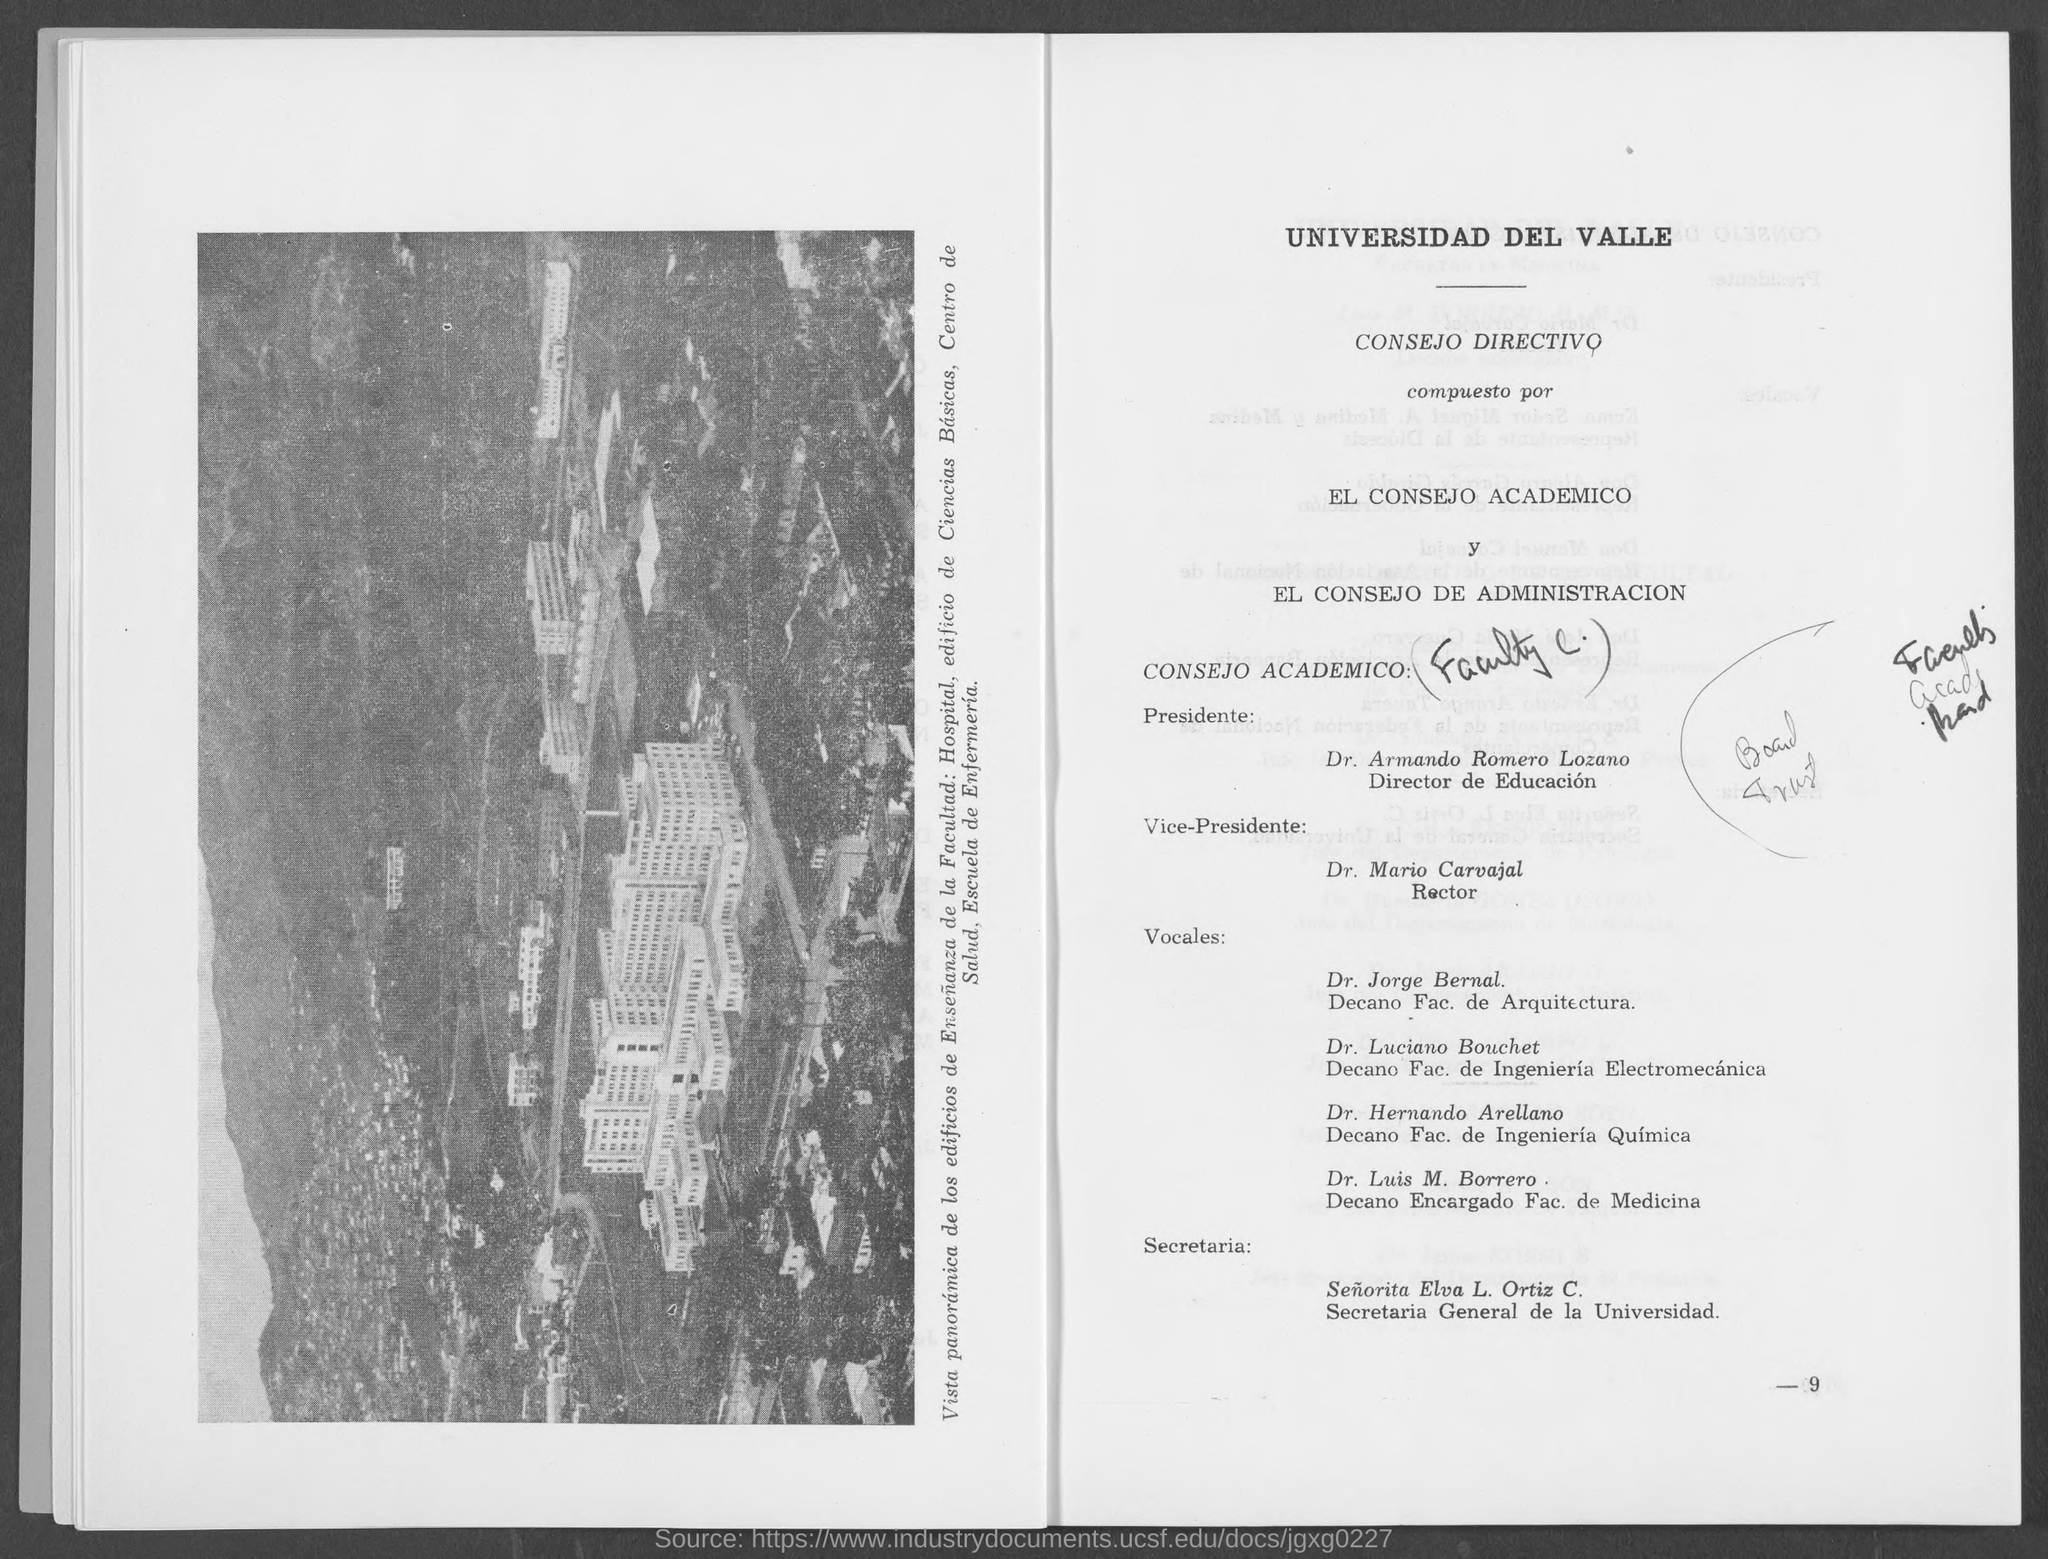Mention the page number given at right bottom corner of the page?
Offer a terse response. -9. 